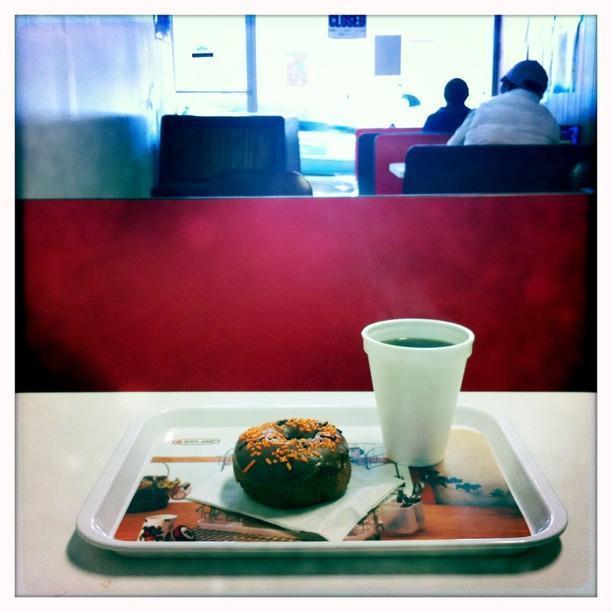How many levels on this bus are red?
Give a very brief answer. 0. 